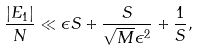Convert formula to latex. <formula><loc_0><loc_0><loc_500><loc_500>\frac { | E _ { 1 } | } { N } \ll \epsilon S + \frac { S } { \sqrt { M } \epsilon ^ { 2 } } + \frac { 1 } { S } ,</formula> 